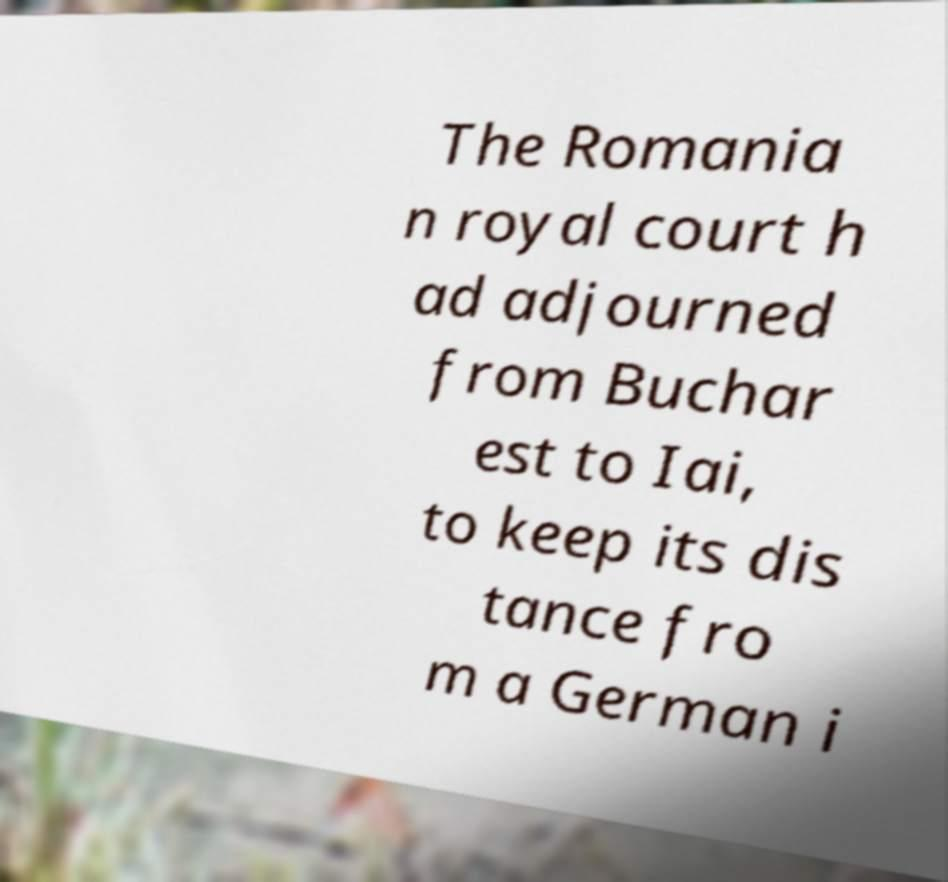There's text embedded in this image that I need extracted. Can you transcribe it verbatim? The Romania n royal court h ad adjourned from Buchar est to Iai, to keep its dis tance fro m a German i 